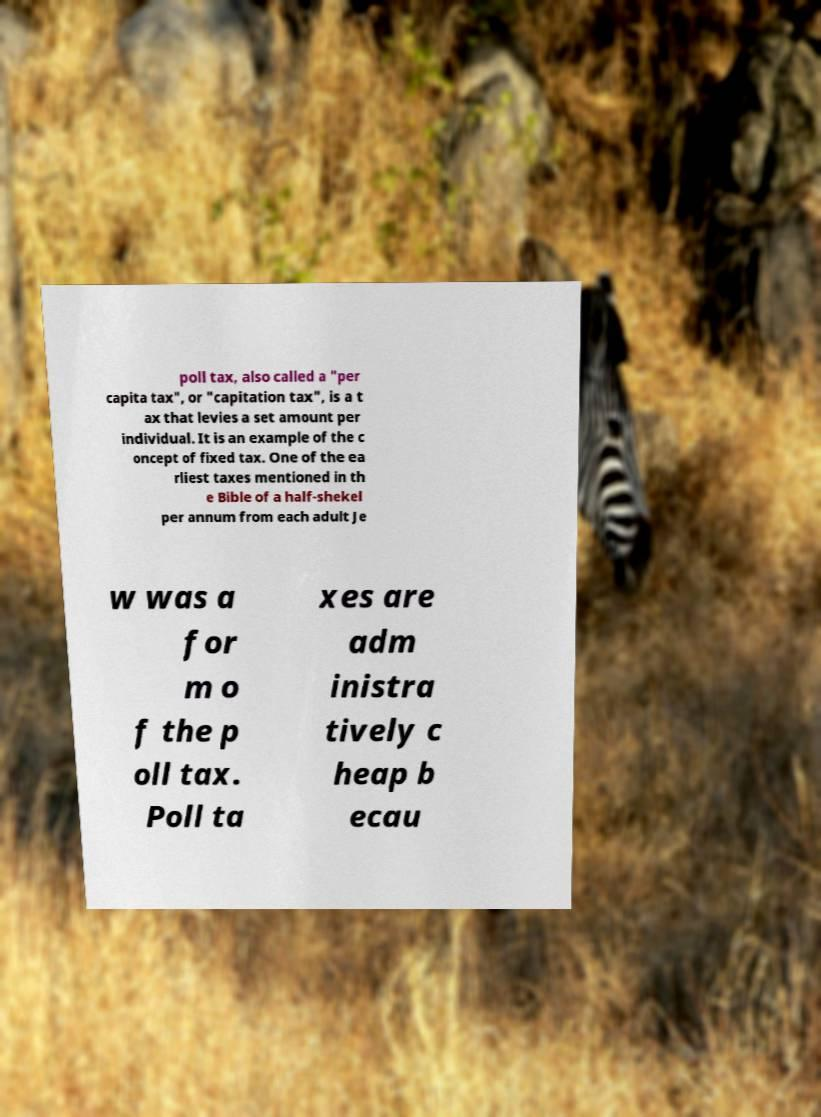There's text embedded in this image that I need extracted. Can you transcribe it verbatim? poll tax, also called a "per capita tax", or "capitation tax", is a t ax that levies a set amount per individual. It is an example of the c oncept of fixed tax. One of the ea rliest taxes mentioned in th e Bible of a half-shekel per annum from each adult Je w was a for m o f the p oll tax. Poll ta xes are adm inistra tively c heap b ecau 